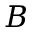Convert formula to latex. <formula><loc_0><loc_0><loc_500><loc_500>B</formula> 